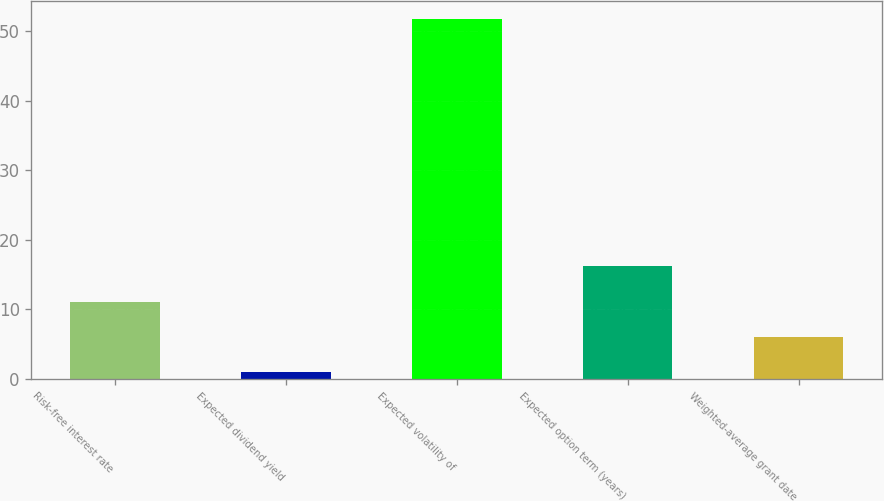Convert chart to OTSL. <chart><loc_0><loc_0><loc_500><loc_500><bar_chart><fcel>Risk-free interest rate<fcel>Expected dividend yield<fcel>Expected volatility of<fcel>Expected option term (years)<fcel>Weighted-average grant date<nl><fcel>11.12<fcel>0.96<fcel>51.8<fcel>16.2<fcel>6.04<nl></chart> 